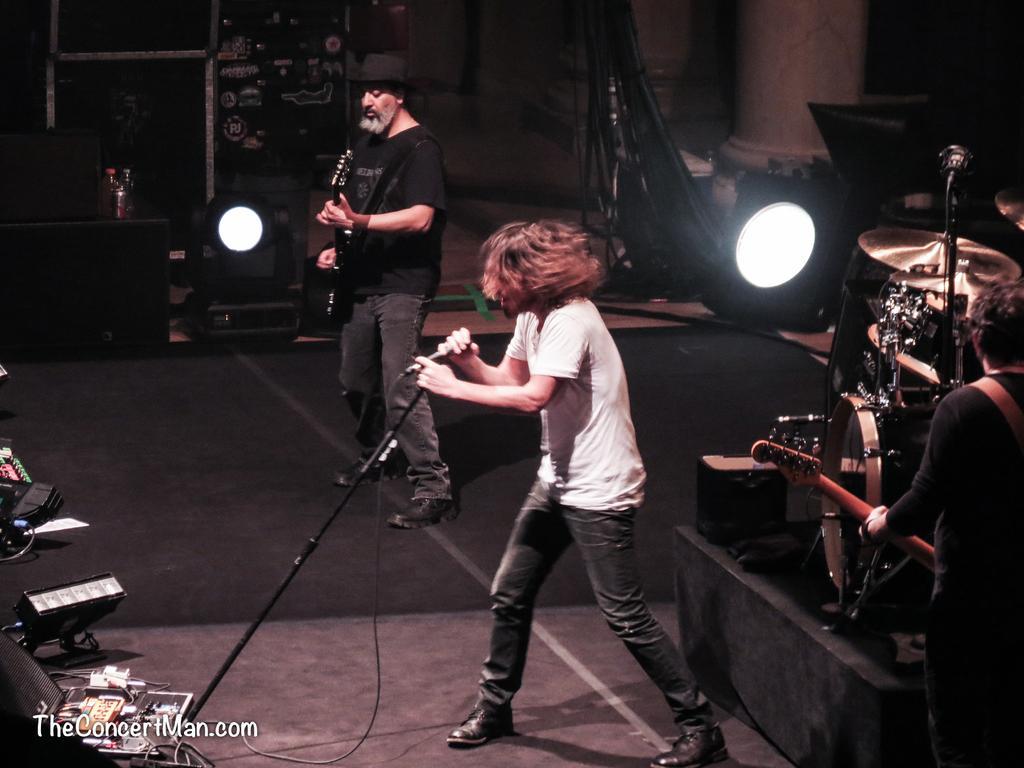Describe this image in one or two sentences. In this picture we can see two persons are standing on the floor. He is singing on the mike and he is playing guitar. Here we can see lights and these are some musical instruments. 